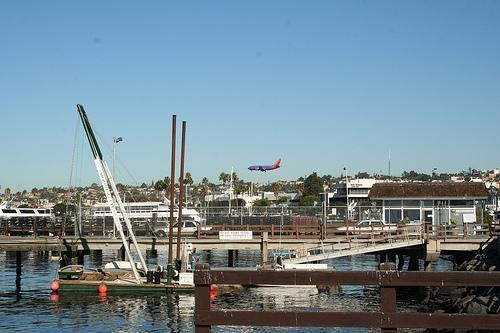How many airplanes?
Give a very brief answer. 1. 